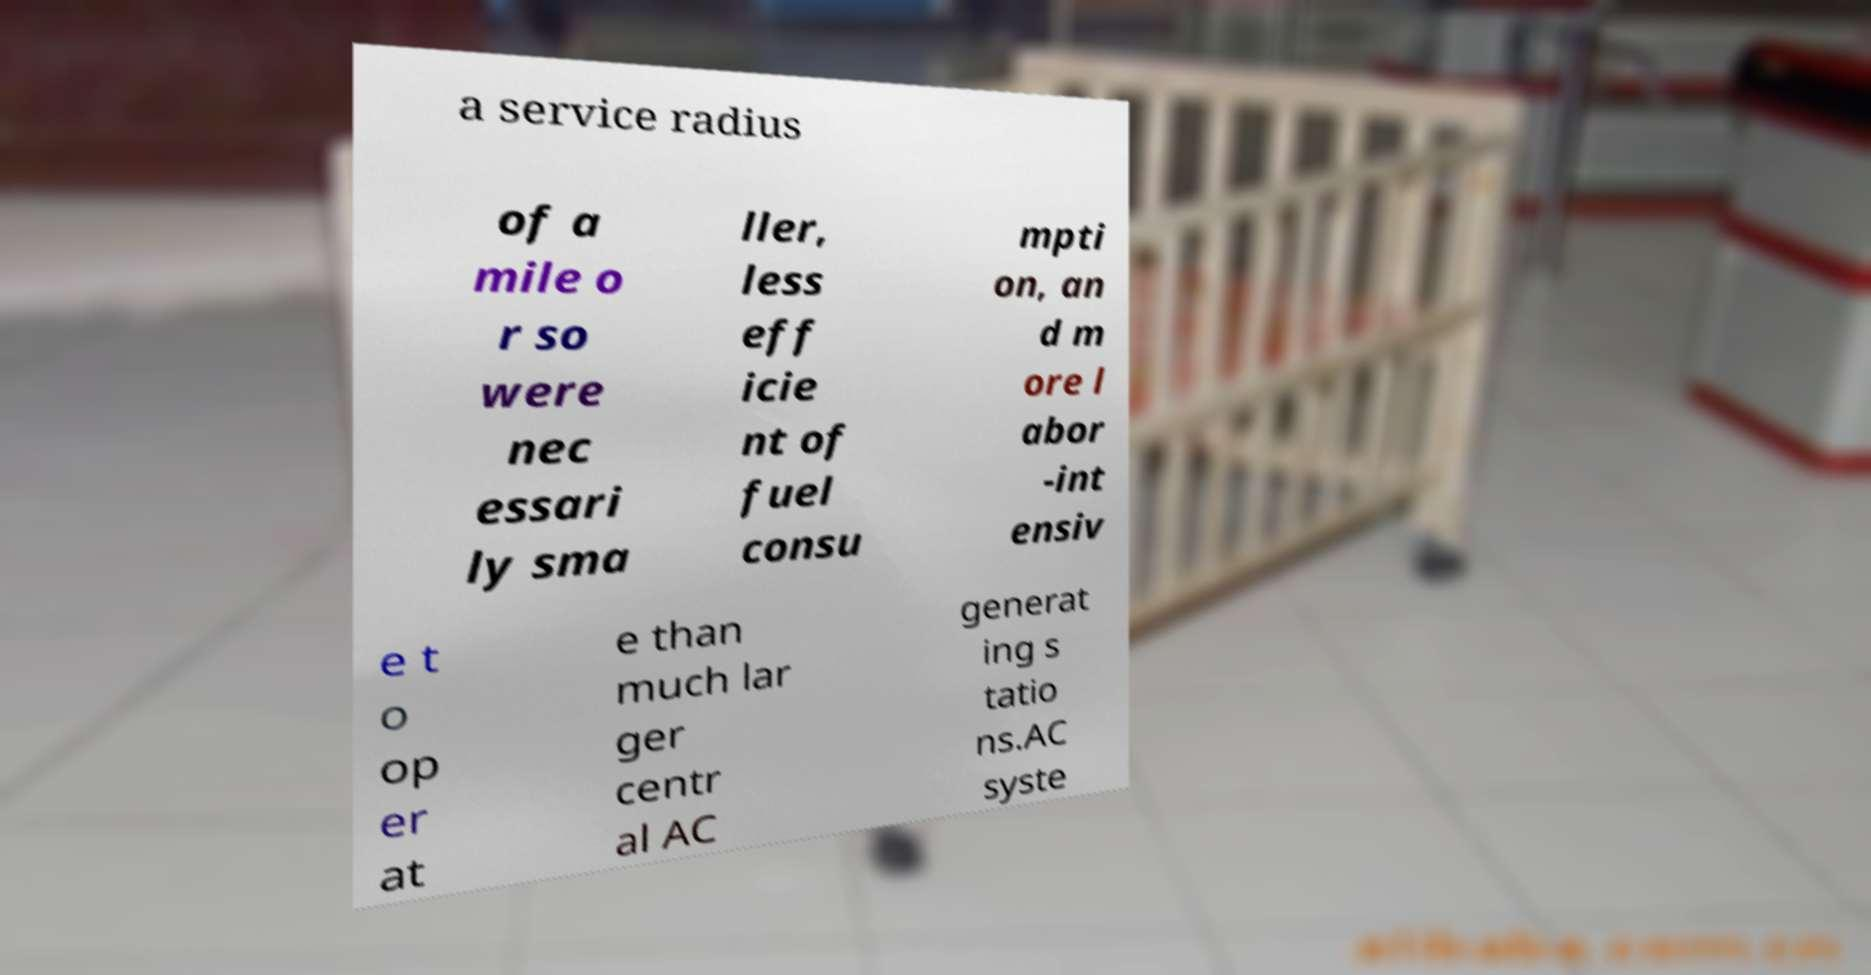For documentation purposes, I need the text within this image transcribed. Could you provide that? a service radius of a mile o r so were nec essari ly sma ller, less eff icie nt of fuel consu mpti on, an d m ore l abor -int ensiv e t o op er at e than much lar ger centr al AC generat ing s tatio ns.AC syste 